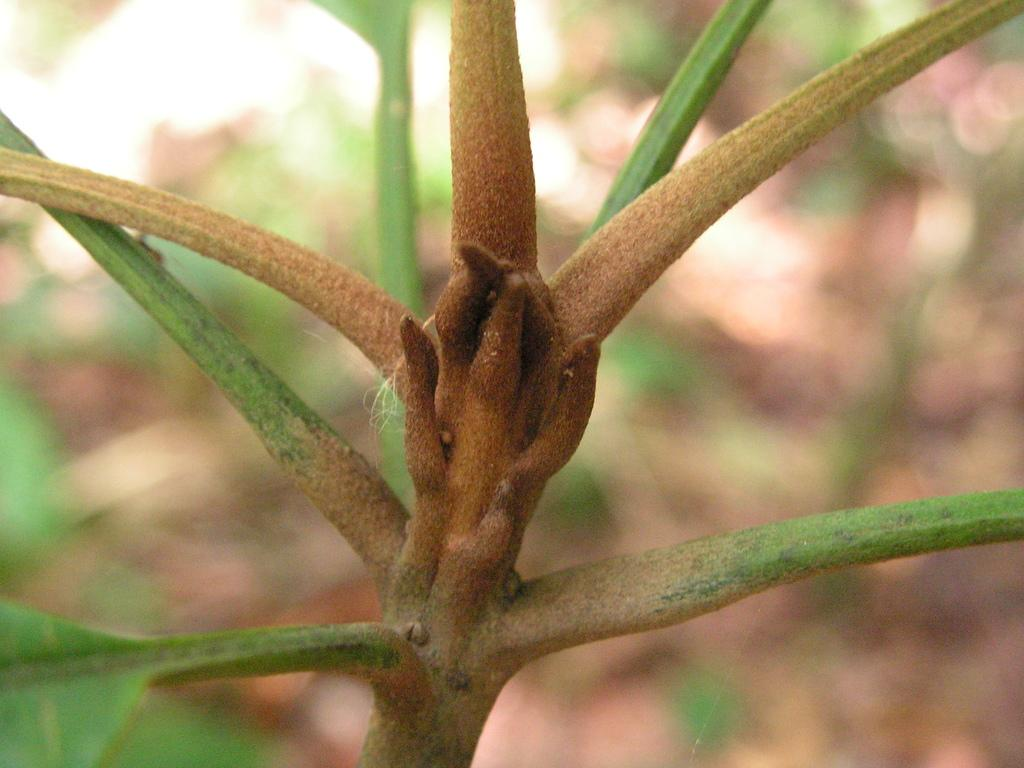What is the main object in the image? There is a branch in the image. Can you describe the colors of the branch? The branch has brown and green colors. What can be seen in the background of the image? The background of the image includes green leaves. What type of string is attached to the branch in the image? There is no string attached to the branch in the image. Can you see any toes on the branch in the image? There are no toes present on the branch in the image. 